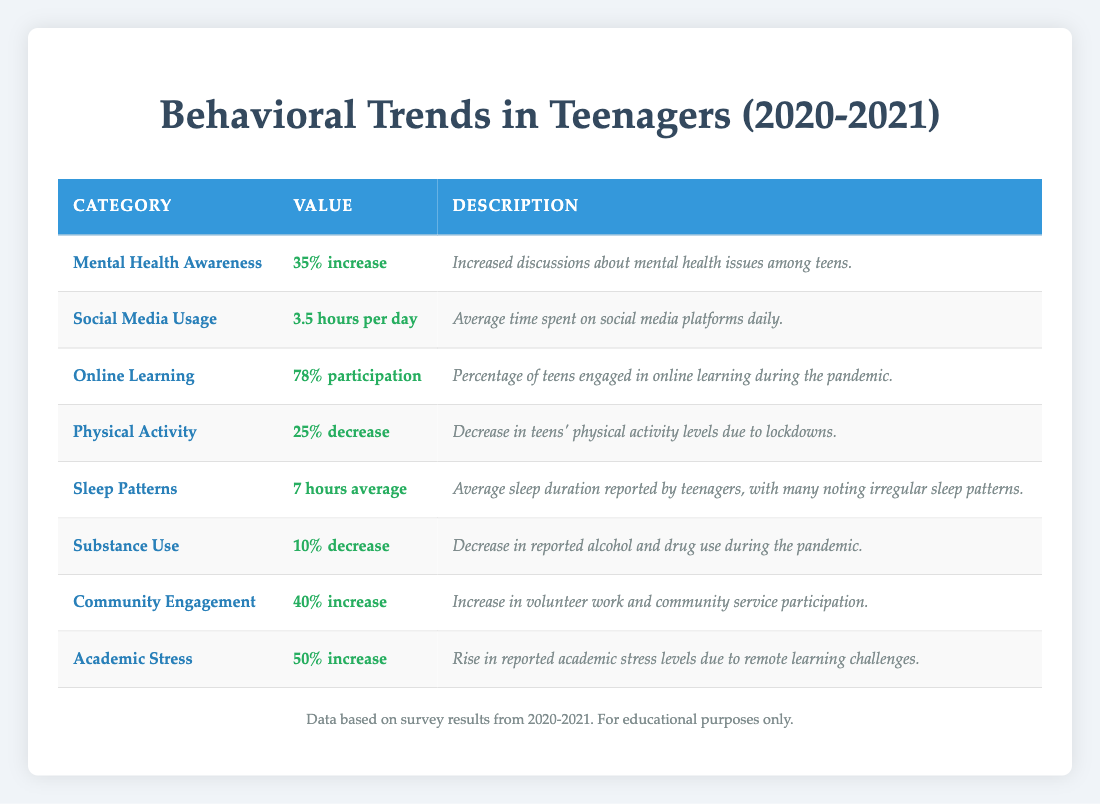What is the average time teenagers spend on social media daily? The table shows that the average time spent on social media platforms daily is 3.5 hours.
Answer: 3.5 hours What percentage of teens participated in online learning during the pandemic? According to the table, 78% of teens engaged in online learning during the pandemic.
Answer: 78% Has there been an increase in mental health awareness among teenagers? The table indicates a 35% increase in discussions about mental health issues among teens, which confirms an increase in mental health awareness.
Answer: Yes What is the percentage decrease in physical activity among teens? The value shown for physical activity indicates a 25% decrease in physical activity levels due to lockdowns.
Answer: 25% What was the increase in academic stress reported by teenagers? The data reveals that there was a 50% increase in reported academic stress levels due to remote learning challenges.
Answer: 50% Is the average sleep duration for teenagers above or below 8 hours? The average sleep duration reported for teenagers is 7 hours, which is below 8 hours.
Answer: Below Calculate the total percentage increase in both mental health awareness and community engagement. To find the total percentage increase, add the percentage increases of mental health awareness (35%) and community engagement (40%). Therefore, 35 + 40 = 75.
Answer: 75% Was there a reported increase or decrease in substance use among teenagers during the pandemic? The table shows a decrease of 10% in reported alcohol and drug use during the pandemic.
Answer: Decrease What combination of changes occurred in mental health awareness, community engagement, and academic stress? The data indicates mental health awareness increased by 35%, community engagement increased by 40%, and academic stress rose by 50%. Together, this shows that while awareness and engagement improved, academic stress also significantly worsened during this period.
Answer: Increased awareness and engagement; increased stress 